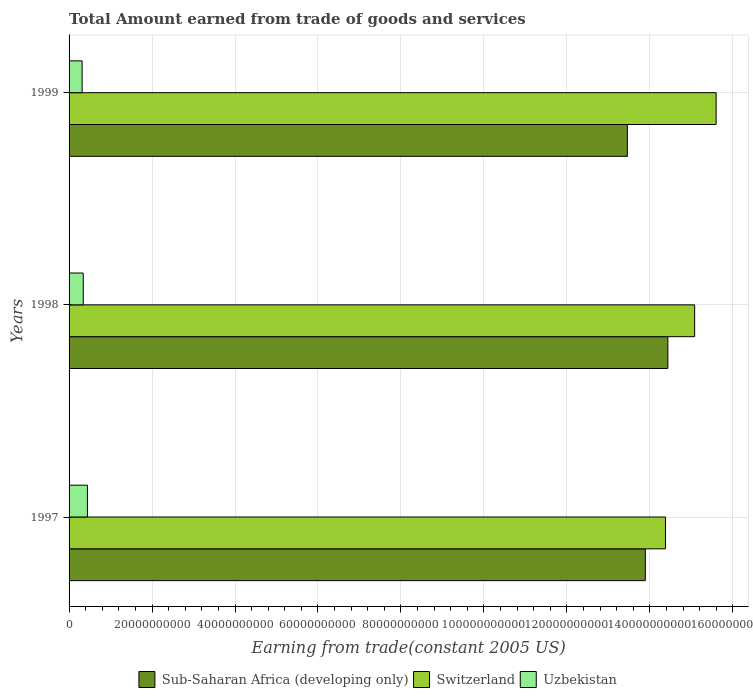How many groups of bars are there?
Provide a short and direct response. 3. In how many cases, is the number of bars for a given year not equal to the number of legend labels?
Provide a short and direct response. 0. What is the total amount earned by trading goods and services in Uzbekistan in 1997?
Make the answer very short. 4.42e+09. Across all years, what is the maximum total amount earned by trading goods and services in Uzbekistan?
Give a very brief answer. 4.42e+09. Across all years, what is the minimum total amount earned by trading goods and services in Switzerland?
Offer a terse response. 1.44e+11. In which year was the total amount earned by trading goods and services in Switzerland maximum?
Give a very brief answer. 1999. What is the total total amount earned by trading goods and services in Uzbekistan in the graph?
Offer a terse response. 1.10e+1. What is the difference between the total amount earned by trading goods and services in Uzbekistan in 1998 and that in 1999?
Your answer should be very brief. 2.73e+08. What is the difference between the total amount earned by trading goods and services in Sub-Saharan Africa (developing only) in 1998 and the total amount earned by trading goods and services in Uzbekistan in 1999?
Provide a short and direct response. 1.41e+11. What is the average total amount earned by trading goods and services in Switzerland per year?
Offer a very short reply. 1.50e+11. In the year 1998, what is the difference between the total amount earned by trading goods and services in Switzerland and total amount earned by trading goods and services in Sub-Saharan Africa (developing only)?
Offer a very short reply. 6.46e+09. In how many years, is the total amount earned by trading goods and services in Uzbekistan greater than 16000000000 US$?
Keep it short and to the point. 0. What is the ratio of the total amount earned by trading goods and services in Switzerland in 1997 to that in 1998?
Give a very brief answer. 0.95. What is the difference between the highest and the second highest total amount earned by trading goods and services in Sub-Saharan Africa (developing only)?
Make the answer very short. 5.43e+09. What is the difference between the highest and the lowest total amount earned by trading goods and services in Sub-Saharan Africa (developing only)?
Your answer should be very brief. 9.76e+09. What does the 3rd bar from the top in 1999 represents?
Make the answer very short. Sub-Saharan Africa (developing only). What does the 2nd bar from the bottom in 1997 represents?
Provide a succinct answer. Switzerland. Is it the case that in every year, the sum of the total amount earned by trading goods and services in Switzerland and total amount earned by trading goods and services in Uzbekistan is greater than the total amount earned by trading goods and services in Sub-Saharan Africa (developing only)?
Offer a very short reply. Yes. How many years are there in the graph?
Make the answer very short. 3. What is the difference between two consecutive major ticks on the X-axis?
Your answer should be very brief. 2.00e+1. How many legend labels are there?
Give a very brief answer. 3. How are the legend labels stacked?
Provide a short and direct response. Horizontal. What is the title of the graph?
Ensure brevity in your answer.  Total Amount earned from trade of goods and services. Does "Aruba" appear as one of the legend labels in the graph?
Offer a very short reply. No. What is the label or title of the X-axis?
Your response must be concise. Earning from trade(constant 2005 US). What is the Earning from trade(constant 2005 US) in Sub-Saharan Africa (developing only) in 1997?
Offer a terse response. 1.39e+11. What is the Earning from trade(constant 2005 US) of Switzerland in 1997?
Ensure brevity in your answer.  1.44e+11. What is the Earning from trade(constant 2005 US) in Uzbekistan in 1997?
Your answer should be very brief. 4.42e+09. What is the Earning from trade(constant 2005 US) of Sub-Saharan Africa (developing only) in 1998?
Ensure brevity in your answer.  1.44e+11. What is the Earning from trade(constant 2005 US) in Switzerland in 1998?
Provide a short and direct response. 1.51e+11. What is the Earning from trade(constant 2005 US) in Uzbekistan in 1998?
Make the answer very short. 3.42e+09. What is the Earning from trade(constant 2005 US) of Sub-Saharan Africa (developing only) in 1999?
Your answer should be very brief. 1.35e+11. What is the Earning from trade(constant 2005 US) in Switzerland in 1999?
Give a very brief answer. 1.56e+11. What is the Earning from trade(constant 2005 US) of Uzbekistan in 1999?
Provide a succinct answer. 3.14e+09. Across all years, what is the maximum Earning from trade(constant 2005 US) of Sub-Saharan Africa (developing only)?
Make the answer very short. 1.44e+11. Across all years, what is the maximum Earning from trade(constant 2005 US) of Switzerland?
Give a very brief answer. 1.56e+11. Across all years, what is the maximum Earning from trade(constant 2005 US) of Uzbekistan?
Ensure brevity in your answer.  4.42e+09. Across all years, what is the minimum Earning from trade(constant 2005 US) of Sub-Saharan Africa (developing only)?
Your response must be concise. 1.35e+11. Across all years, what is the minimum Earning from trade(constant 2005 US) in Switzerland?
Offer a terse response. 1.44e+11. Across all years, what is the minimum Earning from trade(constant 2005 US) of Uzbekistan?
Your response must be concise. 3.14e+09. What is the total Earning from trade(constant 2005 US) in Sub-Saharan Africa (developing only) in the graph?
Your response must be concise. 4.18e+11. What is the total Earning from trade(constant 2005 US) of Switzerland in the graph?
Keep it short and to the point. 4.51e+11. What is the total Earning from trade(constant 2005 US) of Uzbekistan in the graph?
Keep it short and to the point. 1.10e+1. What is the difference between the Earning from trade(constant 2005 US) in Sub-Saharan Africa (developing only) in 1997 and that in 1998?
Offer a very short reply. -5.43e+09. What is the difference between the Earning from trade(constant 2005 US) in Switzerland in 1997 and that in 1998?
Ensure brevity in your answer.  -7.03e+09. What is the difference between the Earning from trade(constant 2005 US) in Uzbekistan in 1997 and that in 1998?
Offer a terse response. 1.01e+09. What is the difference between the Earning from trade(constant 2005 US) in Sub-Saharan Africa (developing only) in 1997 and that in 1999?
Offer a terse response. 4.33e+09. What is the difference between the Earning from trade(constant 2005 US) of Switzerland in 1997 and that in 1999?
Your answer should be compact. -1.22e+1. What is the difference between the Earning from trade(constant 2005 US) in Uzbekistan in 1997 and that in 1999?
Your answer should be very brief. 1.28e+09. What is the difference between the Earning from trade(constant 2005 US) of Sub-Saharan Africa (developing only) in 1998 and that in 1999?
Offer a terse response. 9.76e+09. What is the difference between the Earning from trade(constant 2005 US) in Switzerland in 1998 and that in 1999?
Offer a terse response. -5.18e+09. What is the difference between the Earning from trade(constant 2005 US) of Uzbekistan in 1998 and that in 1999?
Offer a very short reply. 2.73e+08. What is the difference between the Earning from trade(constant 2005 US) in Sub-Saharan Africa (developing only) in 1997 and the Earning from trade(constant 2005 US) in Switzerland in 1998?
Offer a terse response. -1.19e+1. What is the difference between the Earning from trade(constant 2005 US) of Sub-Saharan Africa (developing only) in 1997 and the Earning from trade(constant 2005 US) of Uzbekistan in 1998?
Your response must be concise. 1.35e+11. What is the difference between the Earning from trade(constant 2005 US) of Switzerland in 1997 and the Earning from trade(constant 2005 US) of Uzbekistan in 1998?
Offer a very short reply. 1.40e+11. What is the difference between the Earning from trade(constant 2005 US) in Sub-Saharan Africa (developing only) in 1997 and the Earning from trade(constant 2005 US) in Switzerland in 1999?
Give a very brief answer. -1.71e+1. What is the difference between the Earning from trade(constant 2005 US) in Sub-Saharan Africa (developing only) in 1997 and the Earning from trade(constant 2005 US) in Uzbekistan in 1999?
Your answer should be very brief. 1.36e+11. What is the difference between the Earning from trade(constant 2005 US) in Switzerland in 1997 and the Earning from trade(constant 2005 US) in Uzbekistan in 1999?
Keep it short and to the point. 1.41e+11. What is the difference between the Earning from trade(constant 2005 US) of Sub-Saharan Africa (developing only) in 1998 and the Earning from trade(constant 2005 US) of Switzerland in 1999?
Provide a short and direct response. -1.16e+1. What is the difference between the Earning from trade(constant 2005 US) of Sub-Saharan Africa (developing only) in 1998 and the Earning from trade(constant 2005 US) of Uzbekistan in 1999?
Offer a very short reply. 1.41e+11. What is the difference between the Earning from trade(constant 2005 US) in Switzerland in 1998 and the Earning from trade(constant 2005 US) in Uzbekistan in 1999?
Your answer should be compact. 1.48e+11. What is the average Earning from trade(constant 2005 US) of Sub-Saharan Africa (developing only) per year?
Offer a very short reply. 1.39e+11. What is the average Earning from trade(constant 2005 US) in Switzerland per year?
Your answer should be compact. 1.50e+11. What is the average Earning from trade(constant 2005 US) in Uzbekistan per year?
Make the answer very short. 3.66e+09. In the year 1997, what is the difference between the Earning from trade(constant 2005 US) of Sub-Saharan Africa (developing only) and Earning from trade(constant 2005 US) of Switzerland?
Your answer should be very brief. -4.85e+09. In the year 1997, what is the difference between the Earning from trade(constant 2005 US) of Sub-Saharan Africa (developing only) and Earning from trade(constant 2005 US) of Uzbekistan?
Provide a succinct answer. 1.34e+11. In the year 1997, what is the difference between the Earning from trade(constant 2005 US) in Switzerland and Earning from trade(constant 2005 US) in Uzbekistan?
Your response must be concise. 1.39e+11. In the year 1998, what is the difference between the Earning from trade(constant 2005 US) of Sub-Saharan Africa (developing only) and Earning from trade(constant 2005 US) of Switzerland?
Give a very brief answer. -6.46e+09. In the year 1998, what is the difference between the Earning from trade(constant 2005 US) in Sub-Saharan Africa (developing only) and Earning from trade(constant 2005 US) in Uzbekistan?
Give a very brief answer. 1.41e+11. In the year 1998, what is the difference between the Earning from trade(constant 2005 US) in Switzerland and Earning from trade(constant 2005 US) in Uzbekistan?
Offer a terse response. 1.47e+11. In the year 1999, what is the difference between the Earning from trade(constant 2005 US) of Sub-Saharan Africa (developing only) and Earning from trade(constant 2005 US) of Switzerland?
Ensure brevity in your answer.  -2.14e+1. In the year 1999, what is the difference between the Earning from trade(constant 2005 US) in Sub-Saharan Africa (developing only) and Earning from trade(constant 2005 US) in Uzbekistan?
Your response must be concise. 1.31e+11. In the year 1999, what is the difference between the Earning from trade(constant 2005 US) in Switzerland and Earning from trade(constant 2005 US) in Uzbekistan?
Offer a terse response. 1.53e+11. What is the ratio of the Earning from trade(constant 2005 US) of Sub-Saharan Africa (developing only) in 1997 to that in 1998?
Ensure brevity in your answer.  0.96. What is the ratio of the Earning from trade(constant 2005 US) in Switzerland in 1997 to that in 1998?
Your answer should be compact. 0.95. What is the ratio of the Earning from trade(constant 2005 US) in Uzbekistan in 1997 to that in 1998?
Provide a succinct answer. 1.29. What is the ratio of the Earning from trade(constant 2005 US) of Sub-Saharan Africa (developing only) in 1997 to that in 1999?
Keep it short and to the point. 1.03. What is the ratio of the Earning from trade(constant 2005 US) in Switzerland in 1997 to that in 1999?
Your answer should be very brief. 0.92. What is the ratio of the Earning from trade(constant 2005 US) in Uzbekistan in 1997 to that in 1999?
Ensure brevity in your answer.  1.41. What is the ratio of the Earning from trade(constant 2005 US) in Sub-Saharan Africa (developing only) in 1998 to that in 1999?
Ensure brevity in your answer.  1.07. What is the ratio of the Earning from trade(constant 2005 US) in Switzerland in 1998 to that in 1999?
Ensure brevity in your answer.  0.97. What is the ratio of the Earning from trade(constant 2005 US) of Uzbekistan in 1998 to that in 1999?
Offer a very short reply. 1.09. What is the difference between the highest and the second highest Earning from trade(constant 2005 US) in Sub-Saharan Africa (developing only)?
Provide a short and direct response. 5.43e+09. What is the difference between the highest and the second highest Earning from trade(constant 2005 US) in Switzerland?
Your response must be concise. 5.18e+09. What is the difference between the highest and the second highest Earning from trade(constant 2005 US) of Uzbekistan?
Keep it short and to the point. 1.01e+09. What is the difference between the highest and the lowest Earning from trade(constant 2005 US) in Sub-Saharan Africa (developing only)?
Make the answer very short. 9.76e+09. What is the difference between the highest and the lowest Earning from trade(constant 2005 US) in Switzerland?
Offer a very short reply. 1.22e+1. What is the difference between the highest and the lowest Earning from trade(constant 2005 US) of Uzbekistan?
Ensure brevity in your answer.  1.28e+09. 